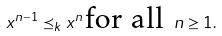Convert formula to latex. <formula><loc_0><loc_0><loc_500><loc_500>x ^ { n - 1 } \preceq _ { k } x ^ { n } \, \text {for all} \, \ n \geq 1 .</formula> 